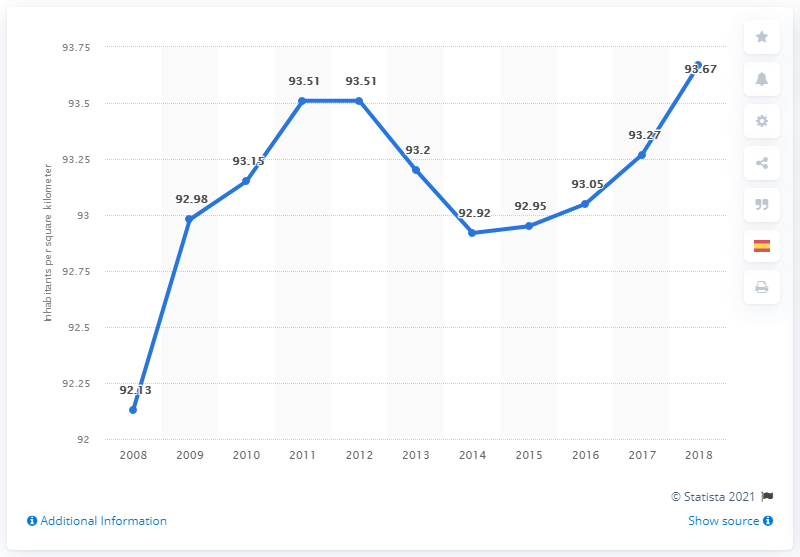Draw attention to some important aspects in this diagram. In 2018, Spain's population density was estimated to be approximately 93.67 people per square kilometer. 